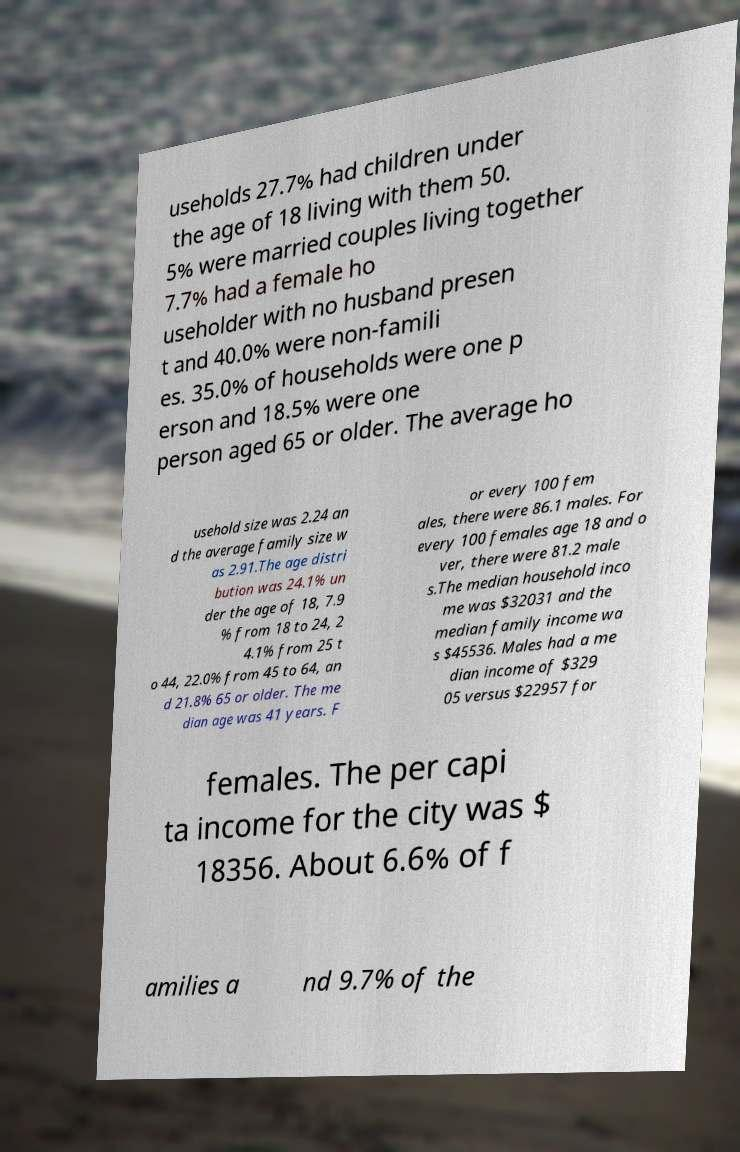Please read and relay the text visible in this image. What does it say? useholds 27.7% had children under the age of 18 living with them 50. 5% were married couples living together 7.7% had a female ho useholder with no husband presen t and 40.0% were non-famili es. 35.0% of households were one p erson and 18.5% were one person aged 65 or older. The average ho usehold size was 2.24 an d the average family size w as 2.91.The age distri bution was 24.1% un der the age of 18, 7.9 % from 18 to 24, 2 4.1% from 25 t o 44, 22.0% from 45 to 64, an d 21.8% 65 or older. The me dian age was 41 years. F or every 100 fem ales, there were 86.1 males. For every 100 females age 18 and o ver, there were 81.2 male s.The median household inco me was $32031 and the median family income wa s $45536. Males had a me dian income of $329 05 versus $22957 for females. The per capi ta income for the city was $ 18356. About 6.6% of f amilies a nd 9.7% of the 